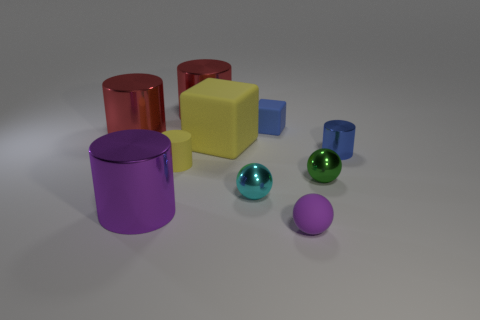Subtract all matte spheres. How many spheres are left? 2 Subtract all cyan spheres. How many spheres are left? 2 Subtract all balls. How many objects are left? 7 Subtract 2 balls. How many balls are left? 1 Subtract all cubes. Subtract all tiny purple matte objects. How many objects are left? 7 Add 3 cylinders. How many cylinders are left? 8 Add 5 yellow cylinders. How many yellow cylinders exist? 6 Subtract 0 blue balls. How many objects are left? 10 Subtract all cyan blocks. Subtract all brown cylinders. How many blocks are left? 2 Subtract all cyan cylinders. How many green balls are left? 1 